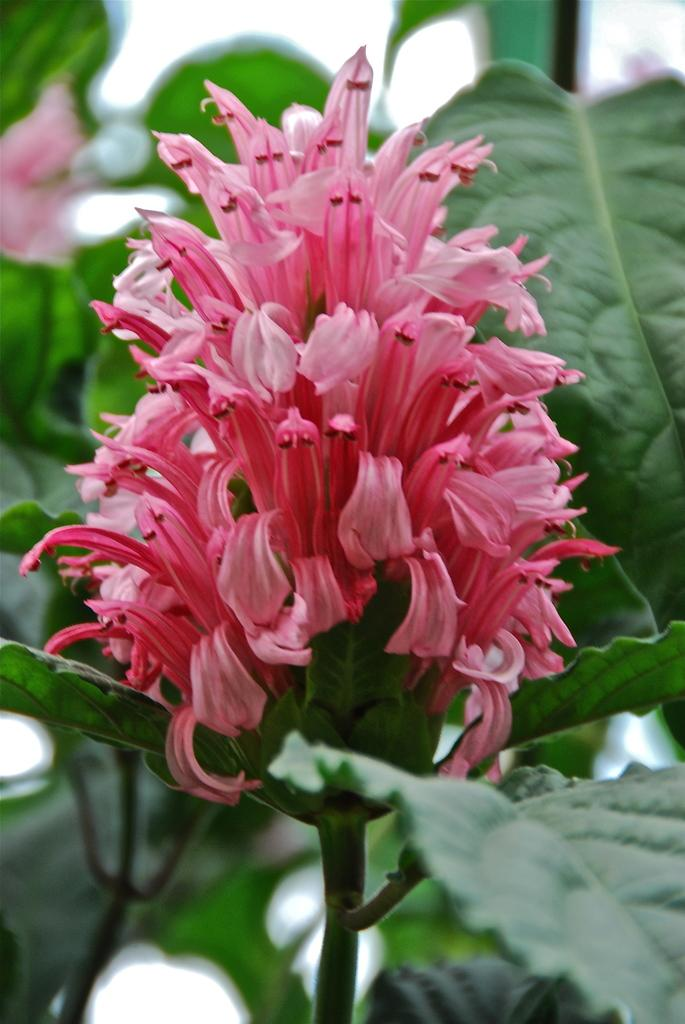What type of flower is present in the image? There is a pink flower in the image. What color are the leaves in the image? The leaves in the image are green. How would you describe the quality of the background in the image? The background of the image is blurry. What type of pump is visible in the image? There is no pump present in the image. What kind of feast is being prepared in the image? There is no feast or preparation visible in the image; it only features a pink flower and green leaves. 